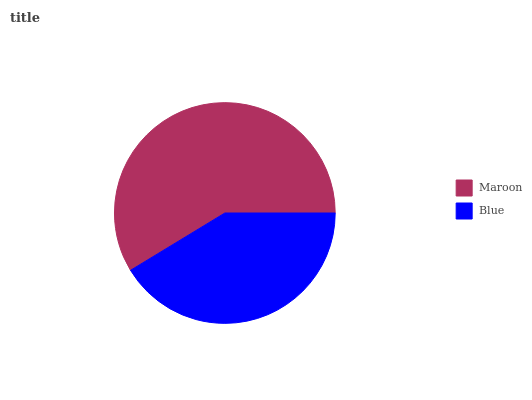Is Blue the minimum?
Answer yes or no. Yes. Is Maroon the maximum?
Answer yes or no. Yes. Is Blue the maximum?
Answer yes or no. No. Is Maroon greater than Blue?
Answer yes or no. Yes. Is Blue less than Maroon?
Answer yes or no. Yes. Is Blue greater than Maroon?
Answer yes or no. No. Is Maroon less than Blue?
Answer yes or no. No. Is Maroon the high median?
Answer yes or no. Yes. Is Blue the low median?
Answer yes or no. Yes. Is Blue the high median?
Answer yes or no. No. Is Maroon the low median?
Answer yes or no. No. 